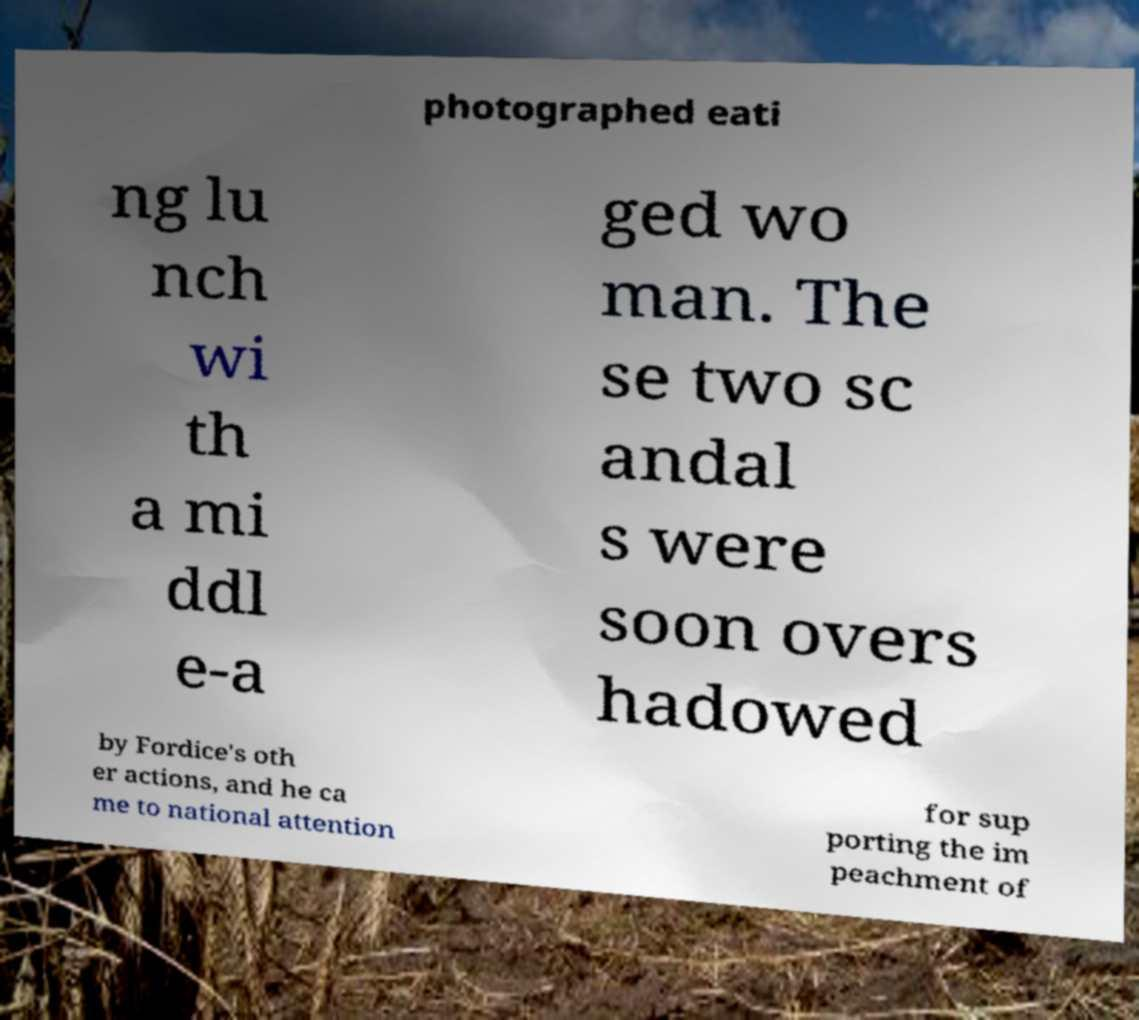There's text embedded in this image that I need extracted. Can you transcribe it verbatim? photographed eati ng lu nch wi th a mi ddl e-a ged wo man. The se two sc andal s were soon overs hadowed by Fordice's oth er actions, and he ca me to national attention for sup porting the im peachment of 